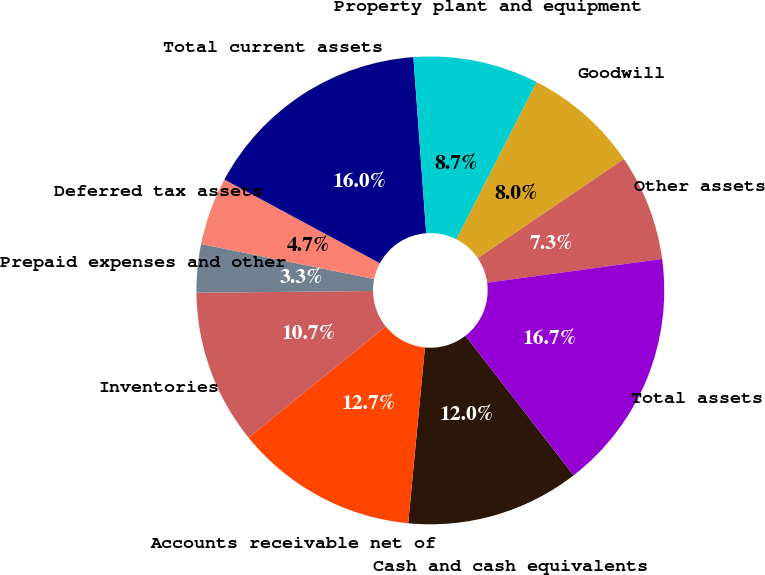Convert chart. <chart><loc_0><loc_0><loc_500><loc_500><pie_chart><fcel>Cash and cash equivalents<fcel>Accounts receivable net of<fcel>Inventories<fcel>Prepaid expenses and other<fcel>Deferred tax assets<fcel>Total current assets<fcel>Property plant and equipment<fcel>Goodwill<fcel>Other assets<fcel>Total assets<nl><fcel>12.0%<fcel>12.66%<fcel>10.67%<fcel>3.34%<fcel>4.68%<fcel>15.99%<fcel>8.67%<fcel>8.0%<fcel>7.34%<fcel>16.66%<nl></chart> 